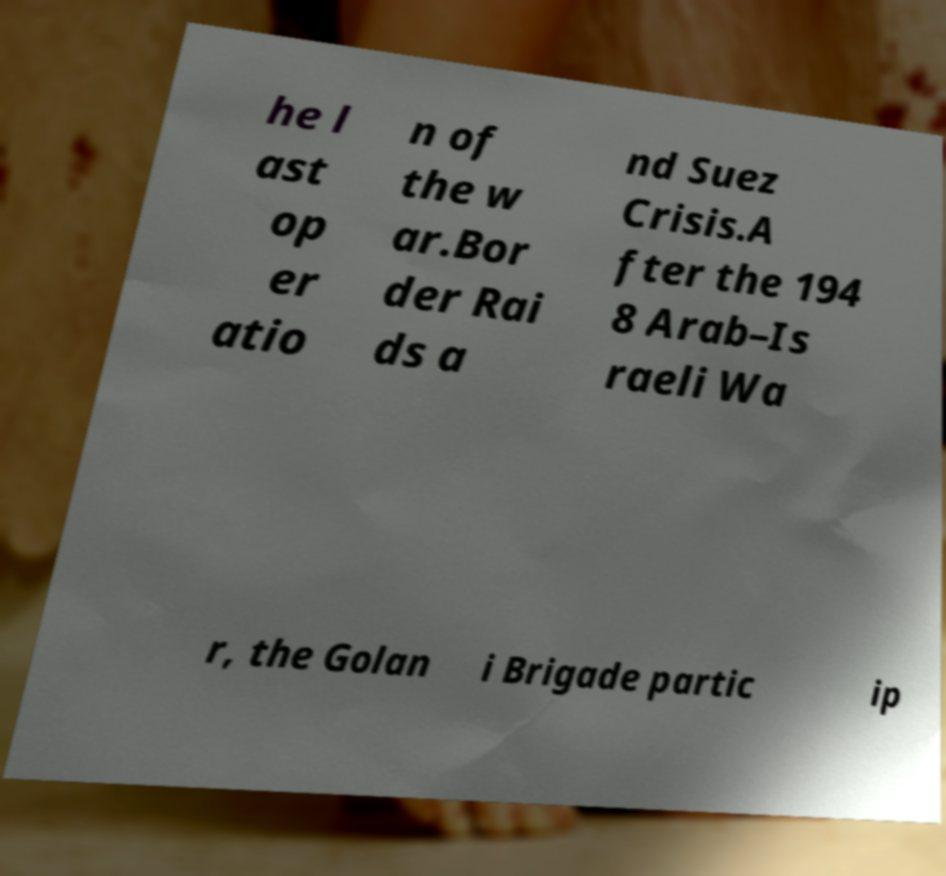Could you extract and type out the text from this image? he l ast op er atio n of the w ar.Bor der Rai ds a nd Suez Crisis.A fter the 194 8 Arab–Is raeli Wa r, the Golan i Brigade partic ip 